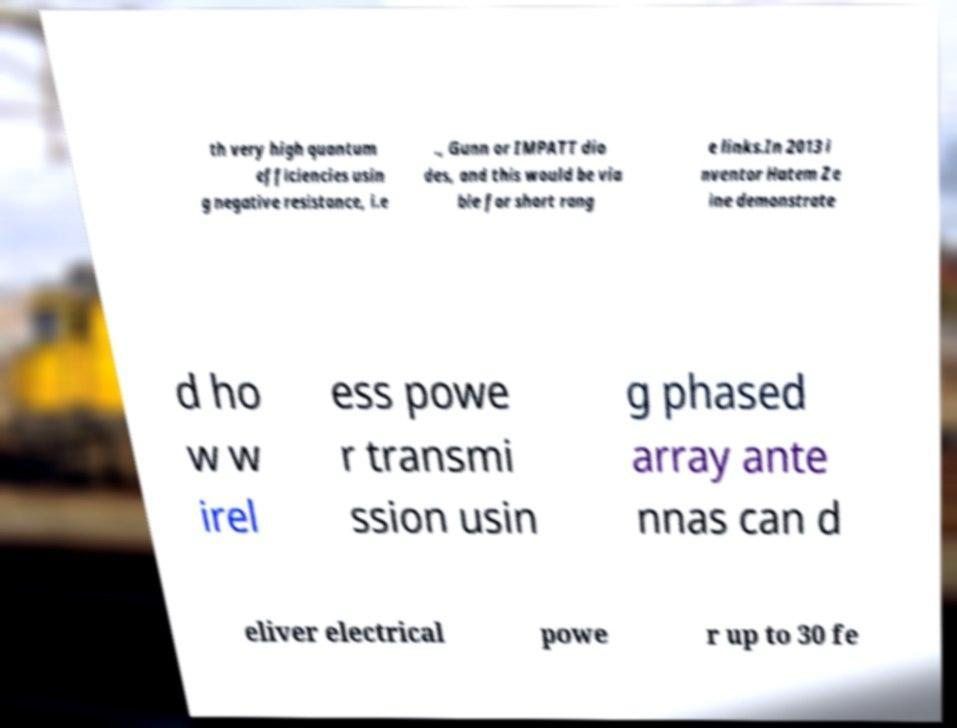Could you assist in decoding the text presented in this image and type it out clearly? th very high quantum efficiencies usin g negative resistance, i.e ., Gunn or IMPATT dio des, and this would be via ble for short rang e links.In 2013 i nventor Hatem Ze ine demonstrate d ho w w irel ess powe r transmi ssion usin g phased array ante nnas can d eliver electrical powe r up to 30 fe 